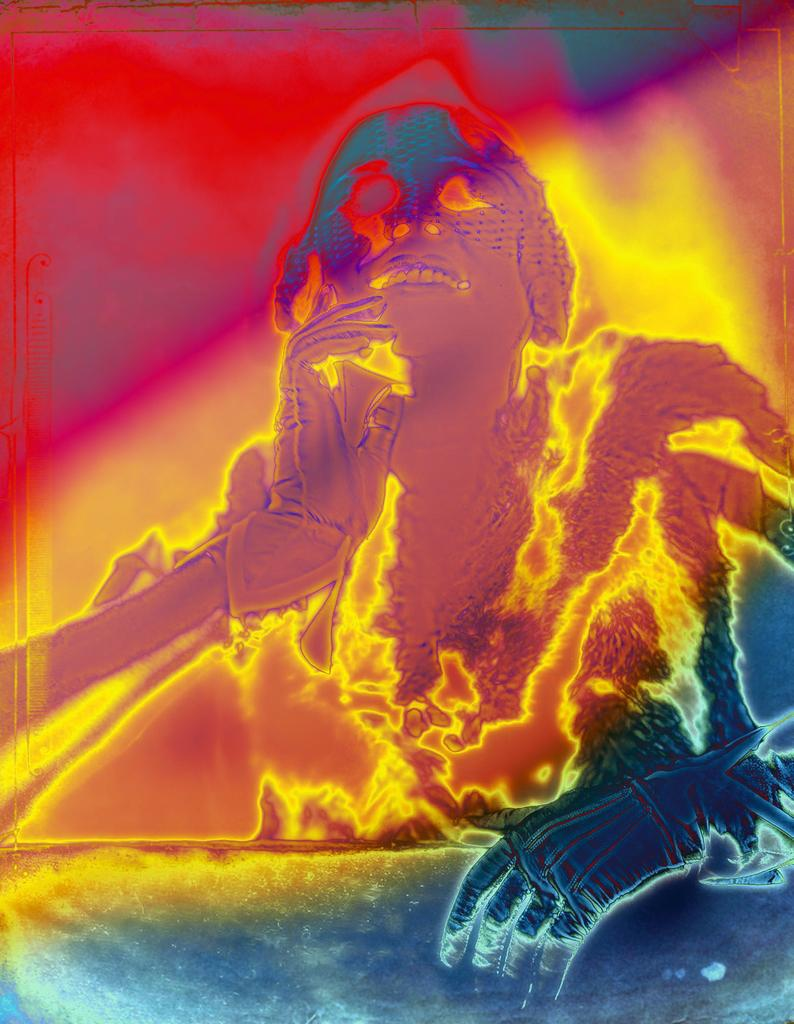What is the main subject of the image? There is a graphic picture of a woman in the image. How many sheep can be seen grazing on the coast in the image? There are no sheep or coast visible in the image; it features a graphic picture of a woman. What type of needle is being used by the woman in the image? There is no needle present in the image; it features a graphic picture of a woman. 